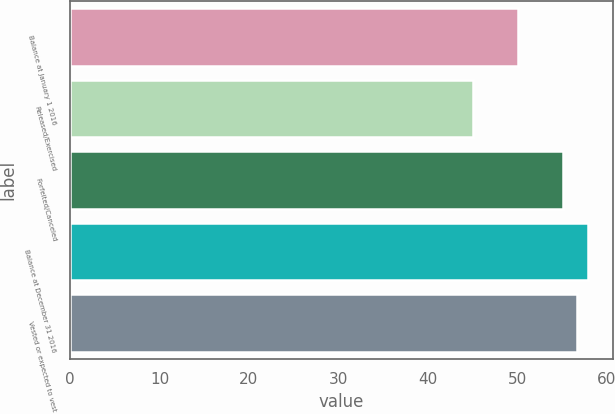Convert chart to OTSL. <chart><loc_0><loc_0><loc_500><loc_500><bar_chart><fcel>Balance at January 1 2016<fcel>Released/Exercised<fcel>Forfeited/Canceled<fcel>Balance at December 31 2016<fcel>Vested or expected to vest<nl><fcel>50.02<fcel>45<fcel>55.06<fcel>57.83<fcel>56.64<nl></chart> 